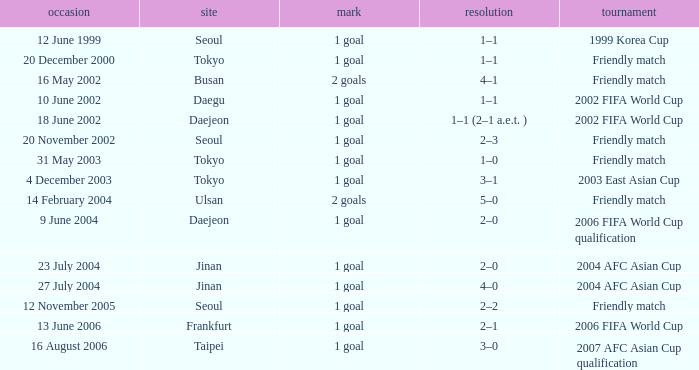What was the score of the game played on 16 August 2006? 1 goal. 